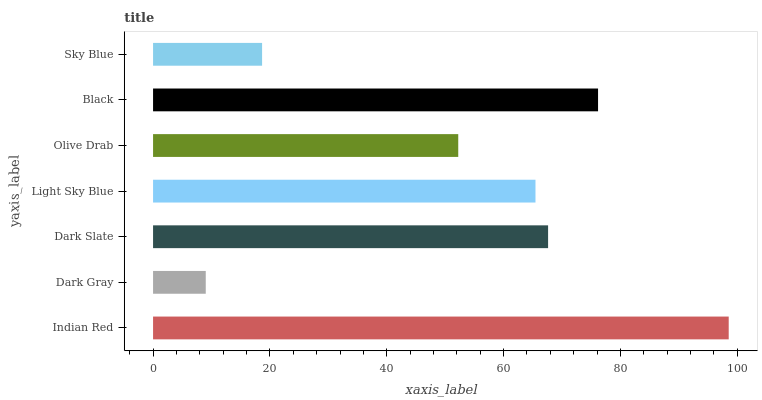Is Dark Gray the minimum?
Answer yes or no. Yes. Is Indian Red the maximum?
Answer yes or no. Yes. Is Dark Slate the minimum?
Answer yes or no. No. Is Dark Slate the maximum?
Answer yes or no. No. Is Dark Slate greater than Dark Gray?
Answer yes or no. Yes. Is Dark Gray less than Dark Slate?
Answer yes or no. Yes. Is Dark Gray greater than Dark Slate?
Answer yes or no. No. Is Dark Slate less than Dark Gray?
Answer yes or no. No. Is Light Sky Blue the high median?
Answer yes or no. Yes. Is Light Sky Blue the low median?
Answer yes or no. Yes. Is Dark Slate the high median?
Answer yes or no. No. Is Black the low median?
Answer yes or no. No. 